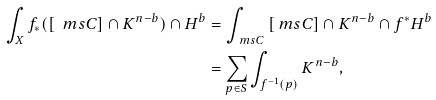<formula> <loc_0><loc_0><loc_500><loc_500>\int _ { X } { f _ { * } ( [ \ m s { C } ] \cap K ^ { n - b } ) \cap H ^ { b } } & = \int _ { \ m s { C } } { [ \ m s { C } ] \cap K ^ { n - b } \cap f ^ { * } H ^ { b } } \\ & = \sum _ { p \in S } { \int _ { f ^ { - 1 } ( p ) } { K ^ { n - b } } } ,</formula> 